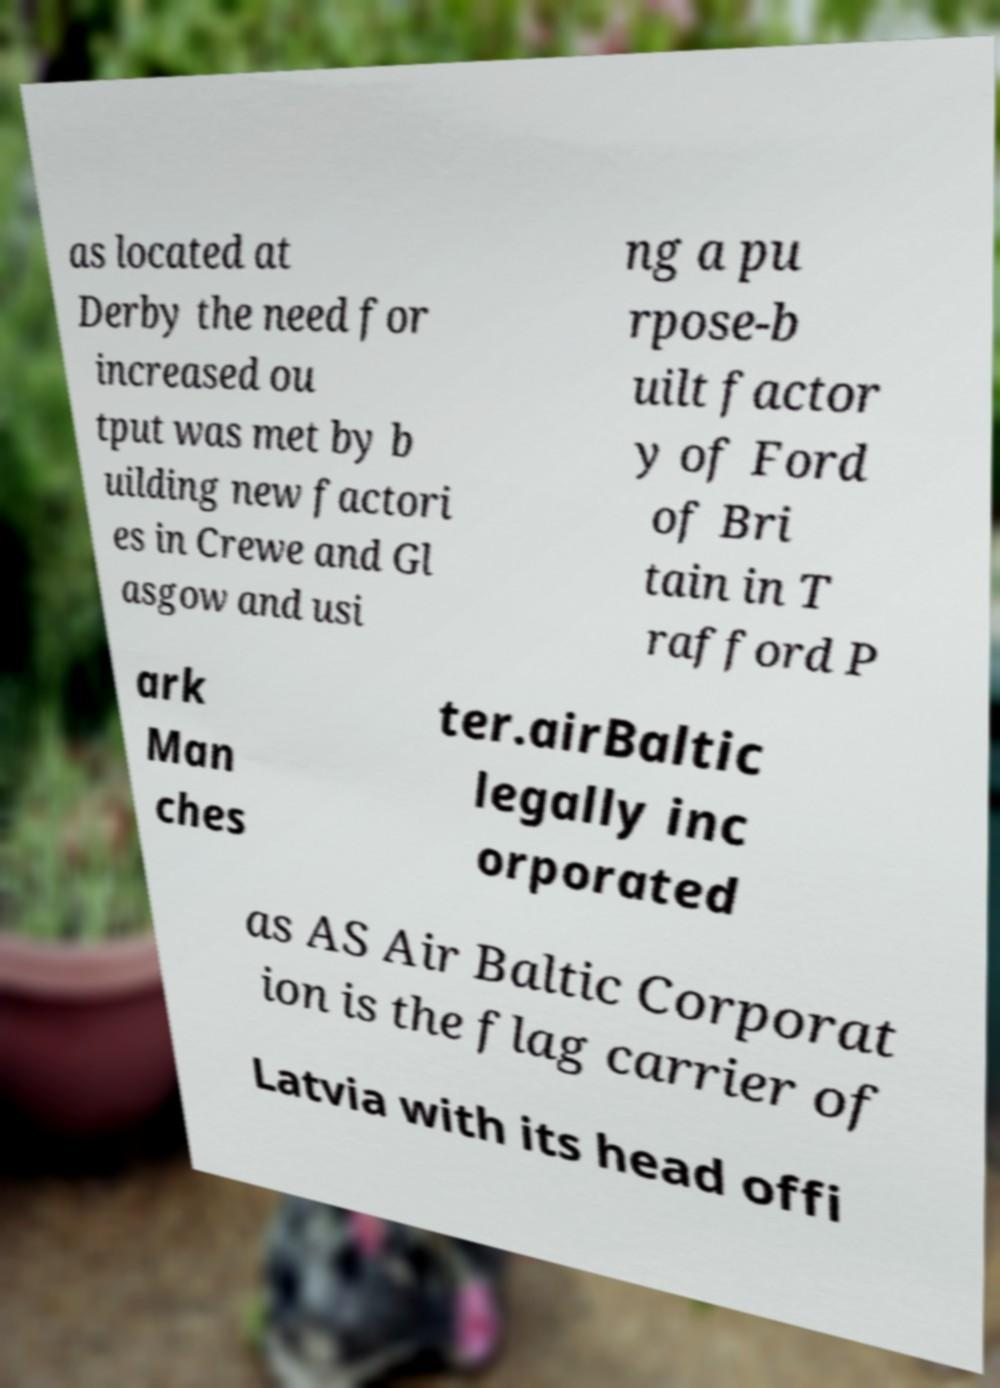Please identify and transcribe the text found in this image. as located at Derby the need for increased ou tput was met by b uilding new factori es in Crewe and Gl asgow and usi ng a pu rpose-b uilt factor y of Ford of Bri tain in T rafford P ark Man ches ter.airBaltic legally inc orporated as AS Air Baltic Corporat ion is the flag carrier of Latvia with its head offi 